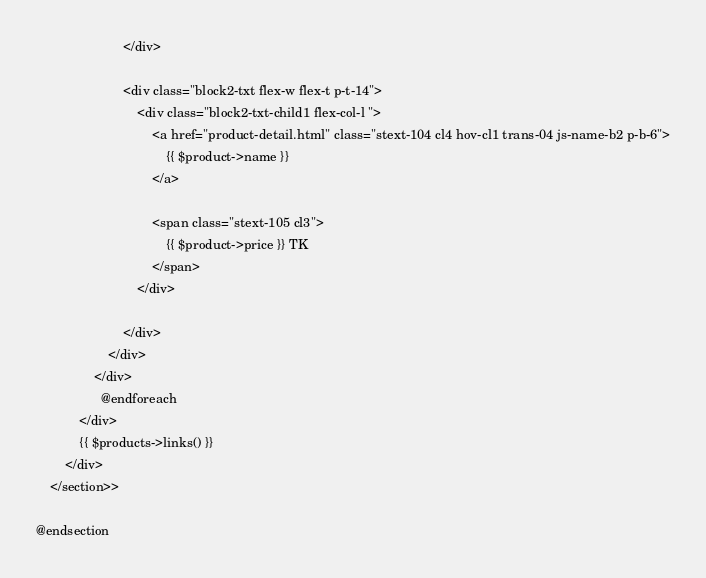<code> <loc_0><loc_0><loc_500><loc_500><_PHP_>						</div>

						<div class="block2-txt flex-w flex-t p-t-14">
							<div class="block2-txt-child1 flex-col-l ">
								<a href="product-detail.html" class="stext-104 cl4 hov-cl1 trans-04 js-name-b2 p-b-6">
                                    {{ $product->name }}
								</a>

								<span class="stext-105 cl3">
									{{ $product->price }} TK
								</span>
							</div>

						</div>
					</div>
				</div>
                  @endforeach
            </div>
            {{ $products->links() }}
		</div>
	</section>>

@endsection
</code> 